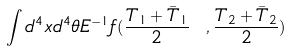<formula> <loc_0><loc_0><loc_500><loc_500>\int d ^ { 4 } x d ^ { 4 } \theta E ^ { - 1 } f ( \frac { T _ { 1 } + \bar { T } _ { 1 } } { 2 } \ , \frac { T _ { 2 } + \bar { T } _ { 2 } } { 2 } )</formula> 